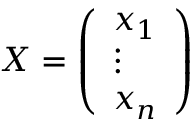<formula> <loc_0><loc_0><loc_500><loc_500>X = { \left ( \begin{array} { l } { x _ { 1 } } \\ { \vdots } \\ { x _ { n } } \end{array} \right ) }</formula> 